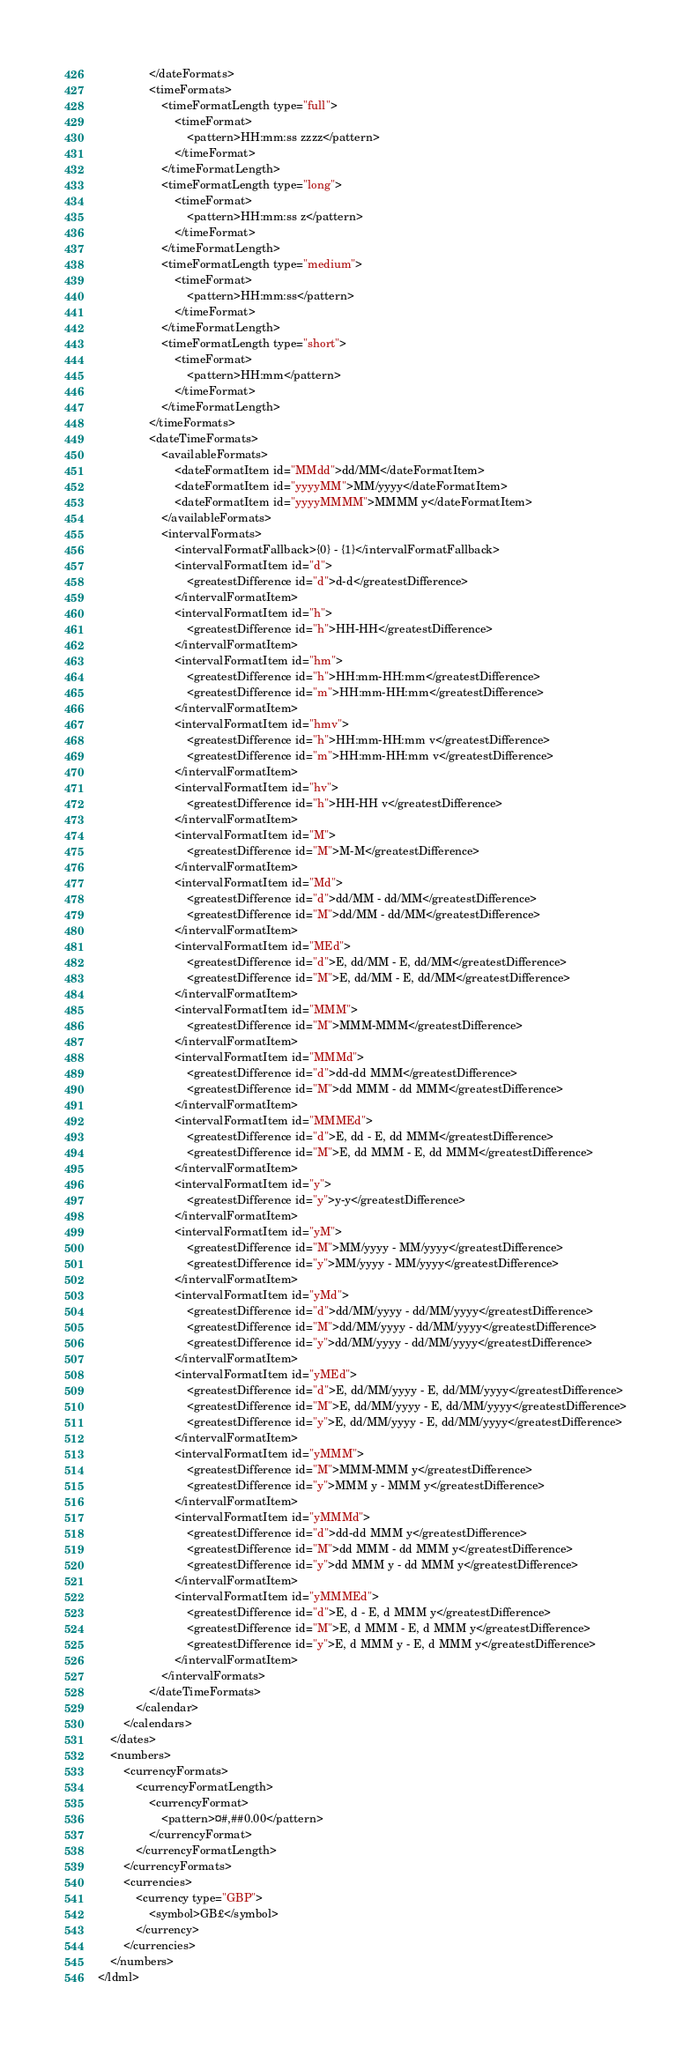<code> <loc_0><loc_0><loc_500><loc_500><_XML_>				</dateFormats>
				<timeFormats>
					<timeFormatLength type="full">
						<timeFormat>
							<pattern>HH:mm:ss zzzz</pattern>
						</timeFormat>
					</timeFormatLength>
					<timeFormatLength type="long">
						<timeFormat>
							<pattern>HH:mm:ss z</pattern>
						</timeFormat>
					</timeFormatLength>
					<timeFormatLength type="medium">
						<timeFormat>
							<pattern>HH:mm:ss</pattern>
						</timeFormat>
					</timeFormatLength>
					<timeFormatLength type="short">
						<timeFormat>
							<pattern>HH:mm</pattern>
						</timeFormat>
					</timeFormatLength>
				</timeFormats>
				<dateTimeFormats>
					<availableFormats>
						<dateFormatItem id="MMdd">dd/MM</dateFormatItem>
						<dateFormatItem id="yyyyMM">MM/yyyy</dateFormatItem>
						<dateFormatItem id="yyyyMMMM">MMMM y</dateFormatItem>
					</availableFormats>
					<intervalFormats>
						<intervalFormatFallback>{0} - {1}</intervalFormatFallback>
						<intervalFormatItem id="d">
							<greatestDifference id="d">d-d</greatestDifference>
						</intervalFormatItem>
						<intervalFormatItem id="h">
							<greatestDifference id="h">HH-HH</greatestDifference>
						</intervalFormatItem>
						<intervalFormatItem id="hm">
							<greatestDifference id="h">HH:mm-HH:mm</greatestDifference>
							<greatestDifference id="m">HH:mm-HH:mm</greatestDifference>
						</intervalFormatItem>
						<intervalFormatItem id="hmv">
							<greatestDifference id="h">HH:mm-HH:mm v</greatestDifference>
							<greatestDifference id="m">HH:mm-HH:mm v</greatestDifference>
						</intervalFormatItem>
						<intervalFormatItem id="hv">
							<greatestDifference id="h">HH-HH v</greatestDifference>
						</intervalFormatItem>
						<intervalFormatItem id="M">
							<greatestDifference id="M">M-M</greatestDifference>
						</intervalFormatItem>
						<intervalFormatItem id="Md">
							<greatestDifference id="d">dd/MM - dd/MM</greatestDifference>
							<greatestDifference id="M">dd/MM - dd/MM</greatestDifference>
						</intervalFormatItem>
						<intervalFormatItem id="MEd">
							<greatestDifference id="d">E, dd/MM - E, dd/MM</greatestDifference>
							<greatestDifference id="M">E, dd/MM - E, dd/MM</greatestDifference>
						</intervalFormatItem>
						<intervalFormatItem id="MMM">
							<greatestDifference id="M">MMM-MMM</greatestDifference>
						</intervalFormatItem>
						<intervalFormatItem id="MMMd">
							<greatestDifference id="d">dd-dd MMM</greatestDifference>
							<greatestDifference id="M">dd MMM - dd MMM</greatestDifference>
						</intervalFormatItem>
						<intervalFormatItem id="MMMEd">
							<greatestDifference id="d">E, dd - E, dd MMM</greatestDifference>
							<greatestDifference id="M">E, dd MMM - E, dd MMM</greatestDifference>
						</intervalFormatItem>
						<intervalFormatItem id="y">
							<greatestDifference id="y">y-y</greatestDifference>
						</intervalFormatItem>
						<intervalFormatItem id="yM">
							<greatestDifference id="M">MM/yyyy - MM/yyyy</greatestDifference>
							<greatestDifference id="y">MM/yyyy - MM/yyyy</greatestDifference>
						</intervalFormatItem>
						<intervalFormatItem id="yMd">
							<greatestDifference id="d">dd/MM/yyyy - dd/MM/yyyy</greatestDifference>
							<greatestDifference id="M">dd/MM/yyyy - dd/MM/yyyy</greatestDifference>
							<greatestDifference id="y">dd/MM/yyyy - dd/MM/yyyy</greatestDifference>
						</intervalFormatItem>
						<intervalFormatItem id="yMEd">
							<greatestDifference id="d">E, dd/MM/yyyy - E, dd/MM/yyyy</greatestDifference>
							<greatestDifference id="M">E, dd/MM/yyyy - E, dd/MM/yyyy</greatestDifference>
							<greatestDifference id="y">E, dd/MM/yyyy - E, dd/MM/yyyy</greatestDifference>
						</intervalFormatItem>
						<intervalFormatItem id="yMMM">
							<greatestDifference id="M">MMM-MMM y</greatestDifference>
							<greatestDifference id="y">MMM y - MMM y</greatestDifference>
						</intervalFormatItem>
						<intervalFormatItem id="yMMMd">
							<greatestDifference id="d">dd-dd MMM y</greatestDifference>
							<greatestDifference id="M">dd MMM - dd MMM y</greatestDifference>
							<greatestDifference id="y">dd MMM y - dd MMM y</greatestDifference>
						</intervalFormatItem>
						<intervalFormatItem id="yMMMEd">
							<greatestDifference id="d">E, d - E, d MMM y</greatestDifference>
							<greatestDifference id="M">E, d MMM - E, d MMM y</greatestDifference>
							<greatestDifference id="y">E, d MMM y - E, d MMM y</greatestDifference>
						</intervalFormatItem>
					</intervalFormats>
				</dateTimeFormats>
			</calendar>
		</calendars>
	</dates>
	<numbers>
		<currencyFormats>
			<currencyFormatLength>
				<currencyFormat>
					<pattern>¤#,##0.00</pattern>
				</currencyFormat>
			</currencyFormatLength>
		</currencyFormats>
		<currencies>
			<currency type="GBP">
				<symbol>GB£</symbol>
			</currency>
		</currencies>
	</numbers>
</ldml>

</code> 